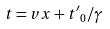<formula> <loc_0><loc_0><loc_500><loc_500>t = v x + { t ^ { \prime } } _ { 0 } / \gamma</formula> 